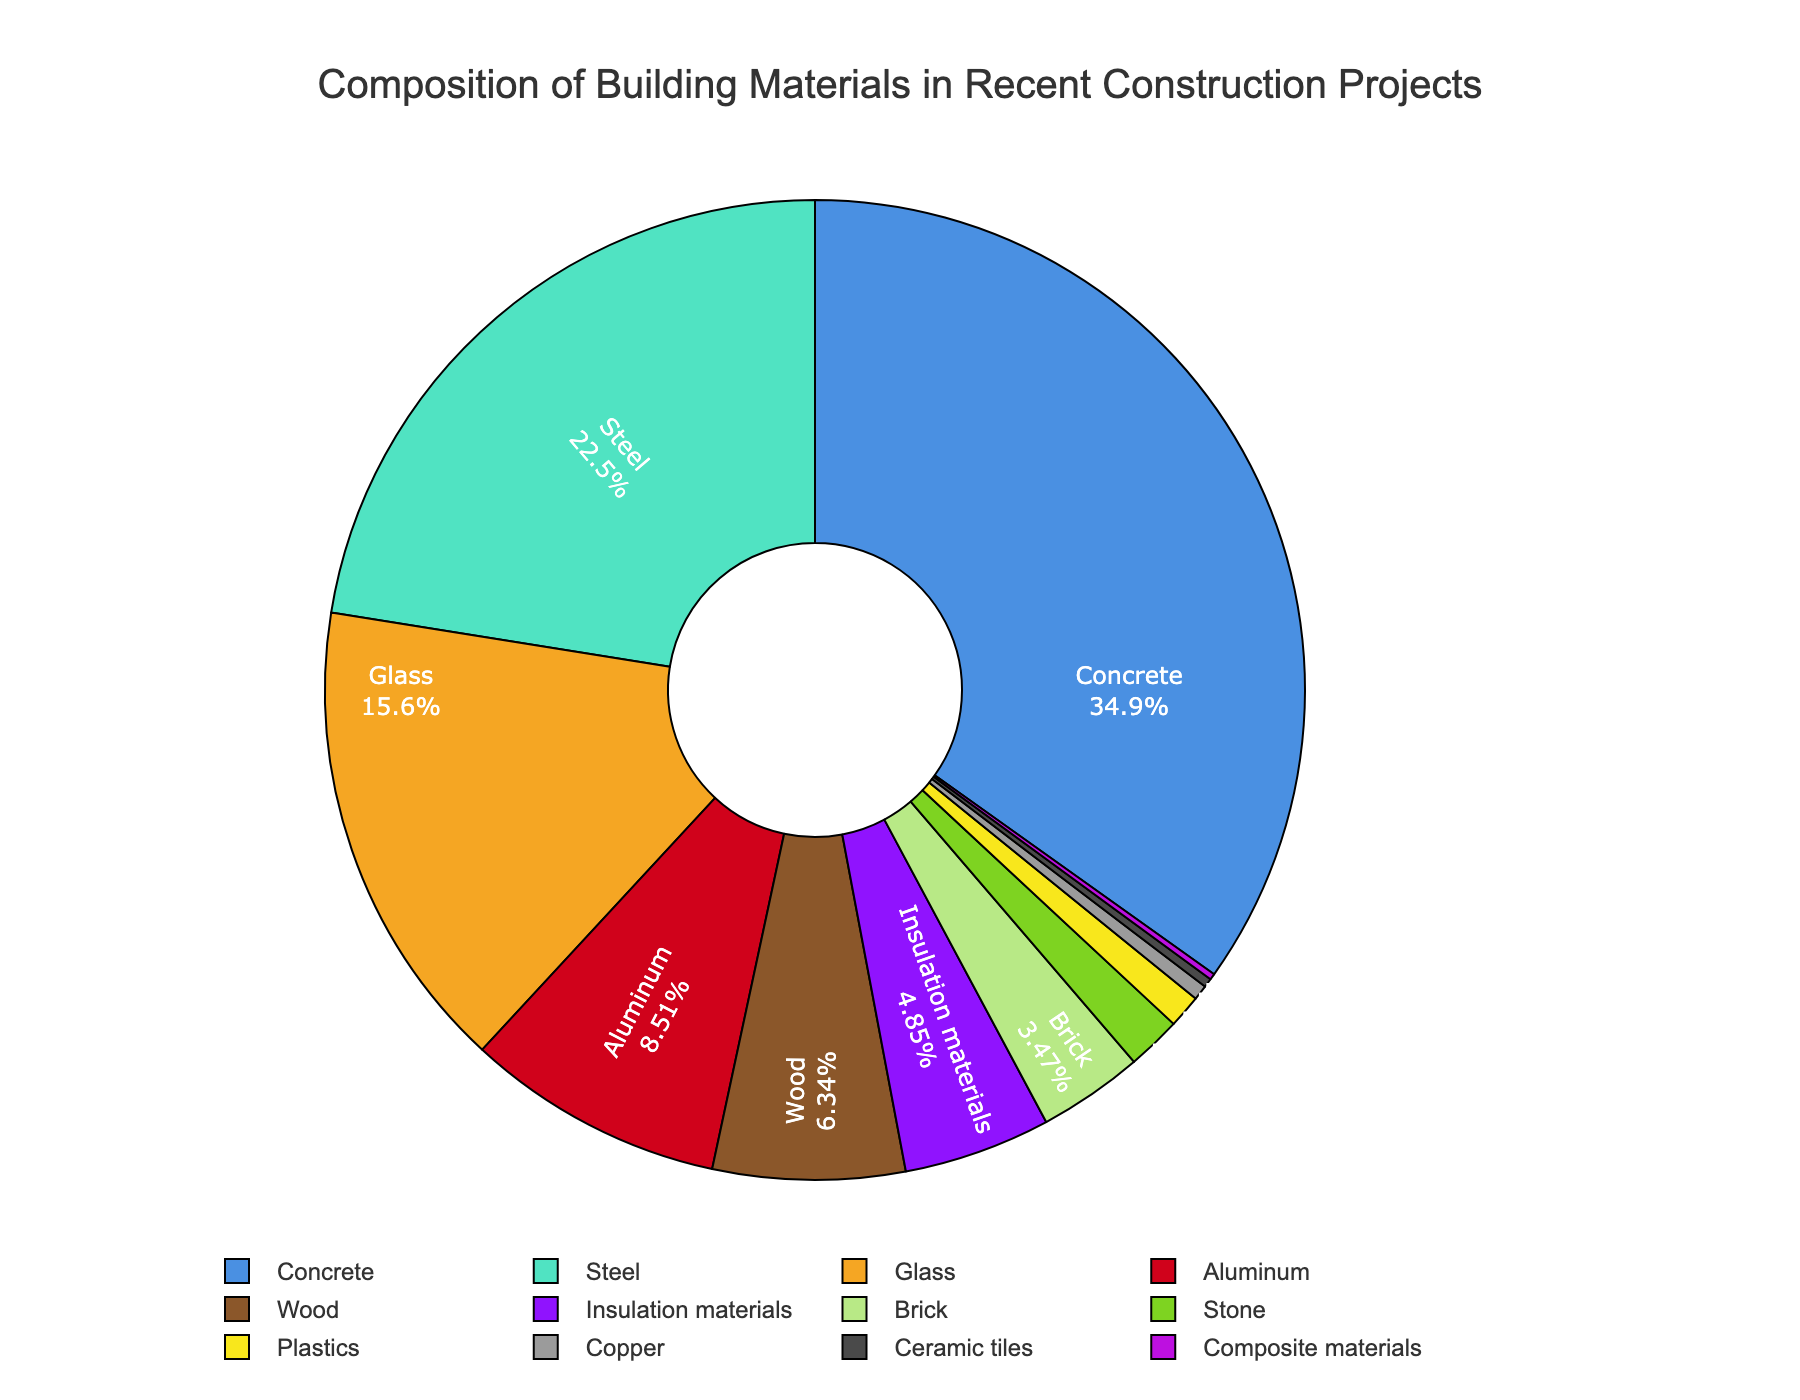What percentage of the building materials is composed of Concrete, Glass, and Brick combined? To find the combined percentage of Concrete, Glass, and Brick, sum their percentages: Concrete (35.2%), Glass (15.8%), and Brick (3.5%). The calculation is: 35.2 + 15.8 + 3.5 = 54.5%.
Answer: 54.5% Which material has a greater percentage: Wood or Aluminum? To compare, check the percentages: Wood (6.4%) and Aluminum (8.6%). Since 8.6% is greater than 6.4%, Aluminum has a greater percentage than Wood.
Answer: Aluminum What is the difference in percentage between the most and least used materials? The most used material is Concrete (35.2%) and the least used material is Composite materials (0.2%). The difference is calculated as: 35.2 - 0.2 = 35%.
Answer: 35% What is the percentage of materials that have less than 5% usage individually? Identify the materials: Insulation materials (4.9%), Brick (3.5%), Stone (1.8%), Plastics (1.1%), Copper (0.5%), Ceramic tiles (0.3%), Composite materials (0.2%). Sum their percentages: 4.9 + 3.5 + 1.8 + 1.1 + 0.5 + 0.3 + 0.2 = 12.3%.
Answer: 12.3% How does the percentage of Steel compare to the combined percentage of Wood and Insulation materials? Compare Steel (22.7%) to the sum of Wood (6.4%) and Insulation materials (4.9%). The combined percentage of Wood and Insulation materials is: 6.4 + 4.9 = 11.3%. Since 22.7% is greater than 11.3%, Steel has a higher percentage.
Answer: Steel What is the percentage difference between Aluminum and Steel? Find the percentages for Aluminum (8.6%) and Steel (22.7%) and calculate the difference: 22.7 - 8.6 = 14.1%.
Answer: 14.1% Are there more materials that comprise more than 10% or less than 10% of the total? Count materials: More than 10% (Concrete, Steel, Glass) = 3 materials. Less than 10% (Aluminum, Wood, Insulation materials, Brick, Stone, Plastics, Copper, Ceramic tiles, Composite materials) = 9 materials. There are more materials comprising less than 10%.
Answer: Less than 10% What is the average percentage of materials used that have more than 1% but less than 10% of the total? Identify materials: Aluminum (8.6%), Wood (6.4%), Insulation materials (4.9%), Brick (3.5%), Stone (1.8%), Plastics (1.1%). Sum these percentages: 8.6 + 6.4 + 4.9 + 3.5 + 1.8 + 1.1 = 26.3. There are 6 materials, so the average is: 26.3 / 6 ≈ 4.38%.
Answer: 4.38% What visual attribute can you use to quickly identify the material representing 22.7%? The material representing 22.7% is Steel. It can be quickly identified by looking for the section that is labeled as "Steel" and has text indicating "22.7%."
Answer: Steel 